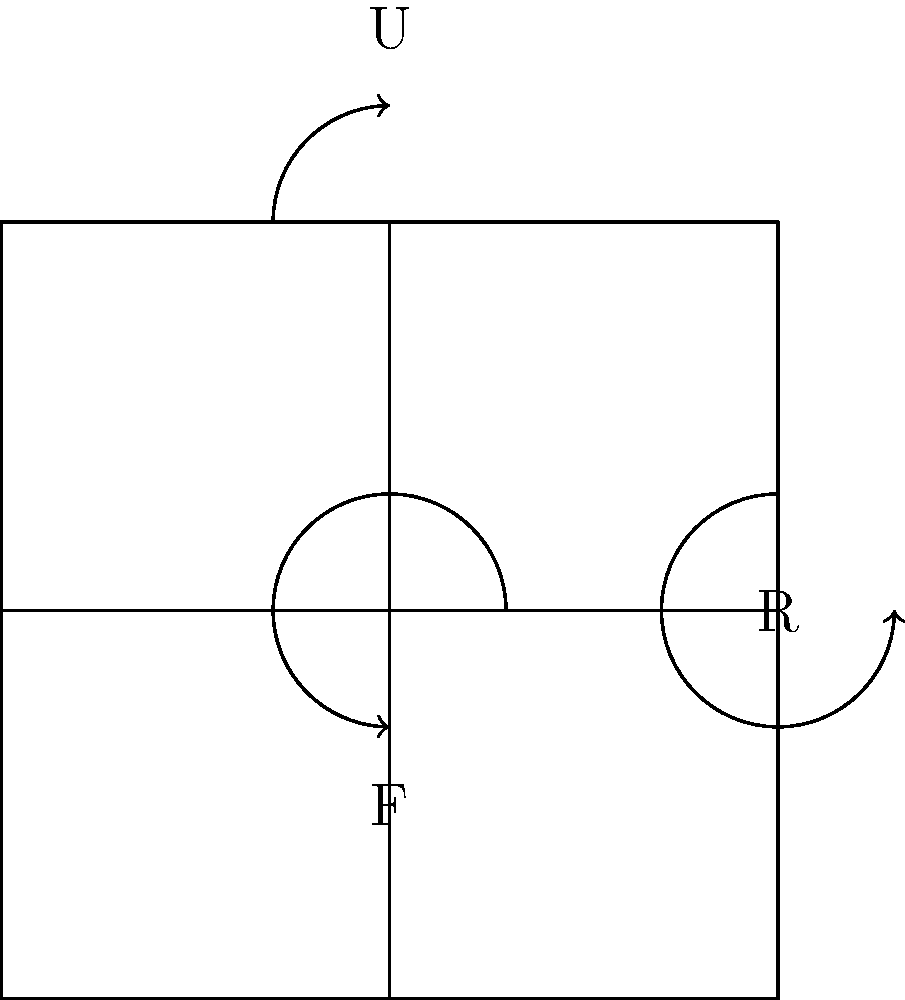In the 2D projection of a Rubik's Cube shown above, consider the group generated by 90-degree clockwise rotations of the Front (F), Right (R), and Up (U) faces. How many elements are in this group? Let's approach this step-by-step:

1) First, we need to understand what each rotation does:
   - F rotates the front face clockwise
   - R rotates the right face clockwise
   - U rotates the upper face clockwise

2) Each face can be in 4 positions (0°, 90°, 180°, 270°), so each rotation has order 4.

3) The group is generated by these three rotations, so we need to consider how they interact:
   - F and R commute (FR = RF)
   - F and U don't commute
   - R and U don't commute

4) Due to the non-commutativity, we can't simply multiply the number of positions for each face.

5) Instead, we can use the orbit-stabilizer theorem. The group acts on the set of all cube configurations.

6) There are 8 corners, each with 3 orientations, and 12 edges, each with 2 orientations.

7) This gives us an upper bound of $8! \cdot 3^8 \cdot 12! \cdot 2^{12}$ configurations.

8) However, not all of these are reachable. There are some constraints:
   - The orientation of the last corner is determined by the others
   - The orientation of the last edge is determined by the others
   - The parity of the corner permutation must match the parity of the edge permutation

9) Taking these into account, the actual number of reachable configurations (and thus the order of the group) is:

   $\frac{8! \cdot 3^7 \cdot 12! \cdot 2^{11}}{2} = 43,252,003,274,489,856,000$
Answer: 43,252,003,274,489,856,000 